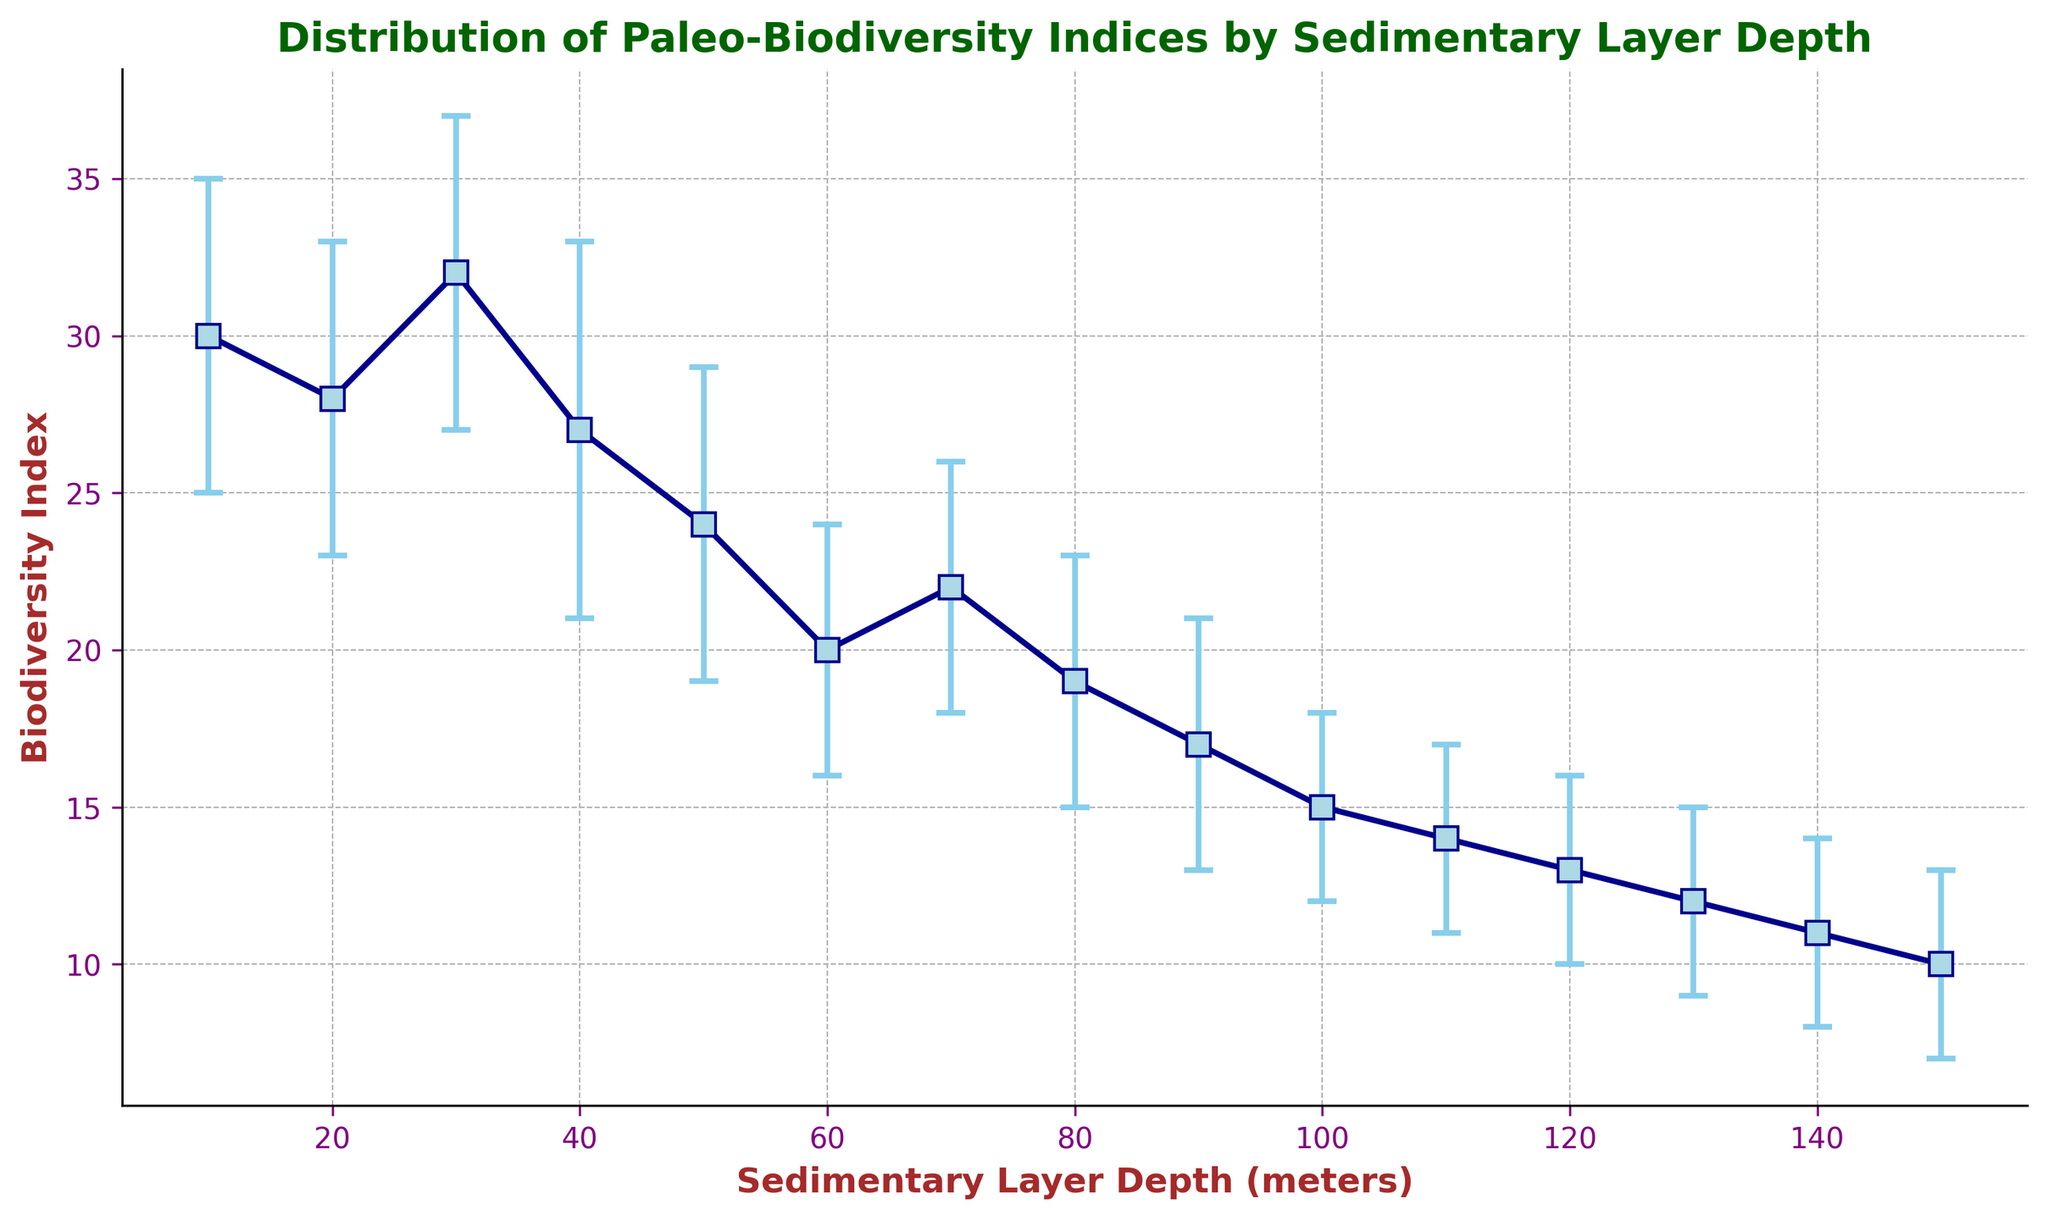What's the biodiversity index at a layer depth of 90 meters? Look at the point where the layer depth is 90 meters. The biodiversity index at this point is 17.
Answer: 17 Which sedimentary layer has the highest biodiversity index? Identify the highest point on the biodiversity index axis. The highest value is at the first data point, indicating a sedimentary layer depth of 10 meters.
Answer: 10 meters By how much did the biodiversity index decrease from 30 meters to 50 meters? At 30 meters, the biodiversity index is 32. At 50 meters, it is 24. The decrease is 32 - 24 = 8.
Answer: 8 What is the average biodiversity index for the depths 20 meters, 40 meters, and 60 meters? The biodiversity indices at these depths are 28, 27, and 20. The average is (28 + 27 + 20) / 3 = 25.
Answer: 25 Is the biodiversity index at 70 meters higher or lower than that at 120 meters? The biodiversity index at 70 meters is 22, and at 120 meters it is 13. Since 22 is greater than 13, the index at 70 meters is higher.
Answer: Higher Which data point has the largest uncertainty band? Uncertainty bands are represented by the error bars. The longest error bars can be seen at the sedimentary depth of 30 meters (32 ± 5), which makes the total uncertainty 10.
Answer: 30 meters What is the difference in the biodiversity index between the sedimentary layers at 80 and 140 meters? The biodiversity index at 80 meters is 19, and at 140 meters it is 11. The difference is 19 - 11 = 8.
Answer: 8 Compare the biodiversity index at 10 meters with the upper bound of the index at 20 meters. The index at 10 meters is 30. The upper bound at 20 meters is 33. Since 33 is greater than 30, the upper bound at 20 meters is higher.
Answer: Higher What is the median biodiversity index of the sedimentary depths provided? Arrange the biodiversity indices in ascending order: [10, 11, 12, 13, 14, 15, 17, 19, 20, 22, 24, 27, 28, 30, 32]. The median value, the middle point of the ordered list, is 17.
Answer: 17 